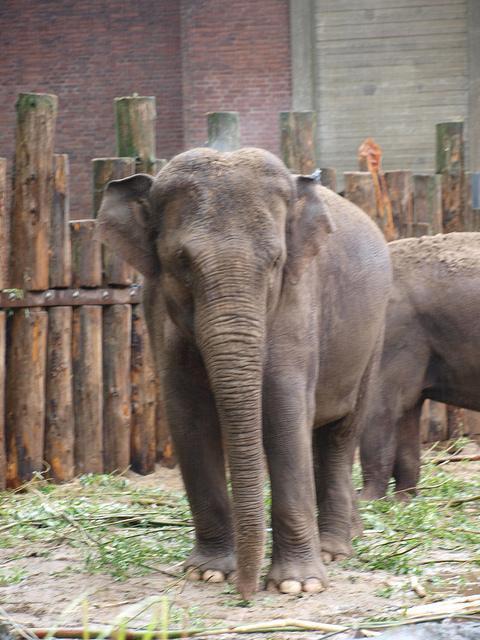How many elephants are there?
Give a very brief answer. 2. How many elephants are visible?
Give a very brief answer. 2. How many people are wearing red shirt?
Give a very brief answer. 0. 